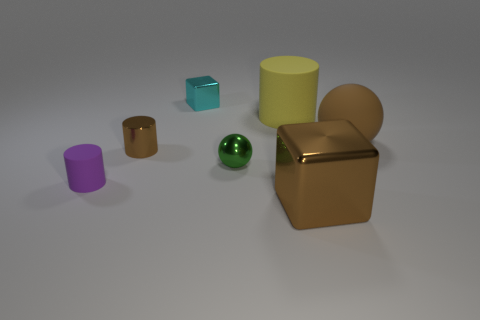Are there any patterns or textures on these objects? No, the objects do not display any patterns or textures. They all have smooth surfaces that reflect the light differently based on their material properties. 